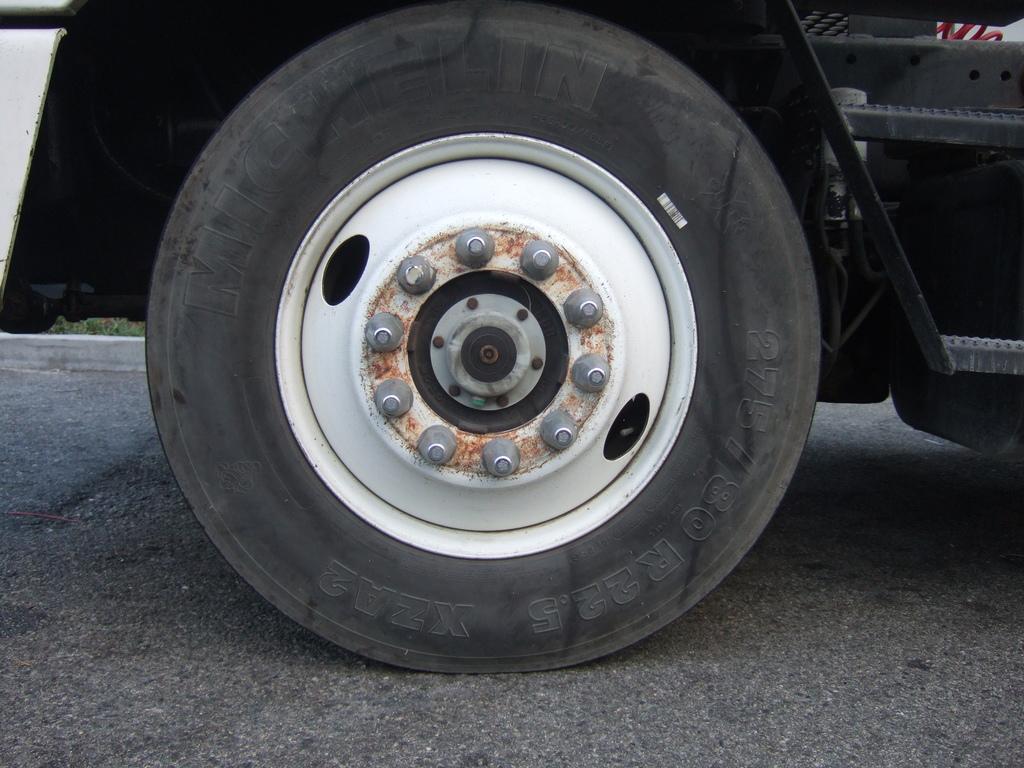Could you give a brief overview of what you see in this image? In the picture we can see a part of the vehicle with tire, rim and nuts to it and it is parked on the road. 